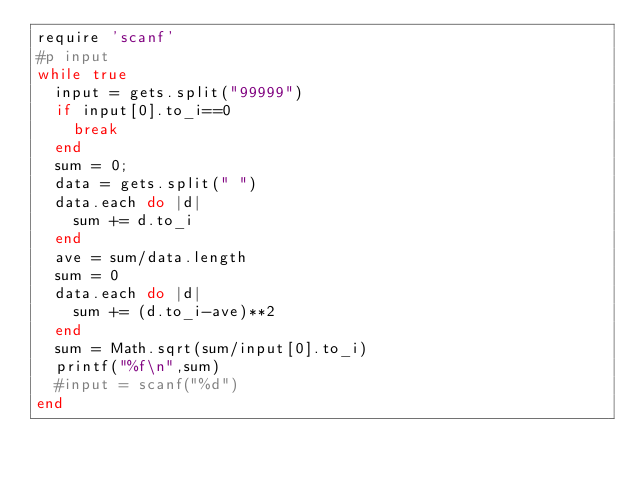Convert code to text. <code><loc_0><loc_0><loc_500><loc_500><_Ruby_>require 'scanf'
#p input
while true
	input = gets.split("99999")
	if input[0].to_i==0
		break
	end
	sum = 0;
	data = gets.split(" ")
	data.each do |d|
		sum += d.to_i
	end
	ave = sum/data.length
	sum = 0
	data.each do |d|
		sum += (d.to_i-ave)**2
	end
	sum = Math.sqrt(sum/input[0].to_i)
	printf("%f\n",sum)
	#input = scanf("%d")
end</code> 